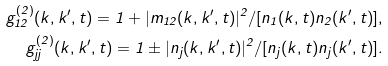<formula> <loc_0><loc_0><loc_500><loc_500>g _ { 1 2 } ^ { ( 2 ) } ( k , k ^ { \prime } , t ) = 1 + | m _ { 1 2 } ( k , k ^ { \prime } , t ) | ^ { 2 } / [ n _ { 1 } ( k , t ) n _ { 2 } ( k ^ { \prime } , t ) ] , \\ g _ { j j } ^ { ( 2 ) } ( k , k ^ { \prime } , t ) = 1 \pm | n _ { j } ( k , k ^ { \prime } , t ) | ^ { 2 } / [ n _ { j } ( k , t ) n _ { j } ( k ^ { \prime } , t ) ] .</formula> 